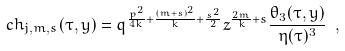Convert formula to latex. <formula><loc_0><loc_0><loc_500><loc_500>c h _ { j , m , s } ( \tau , y ) = q ^ { \frac { p ^ { 2 } } { 4 k } + \frac { ( m + s ) ^ { 2 } } { k } + \frac { s ^ { 2 } } { 2 } } z ^ { \frac { 2 m } { k } + s } \frac { \theta _ { 3 } ( \tau , y ) } { \eta ( \tau ) ^ { 3 } } \ ,</formula> 